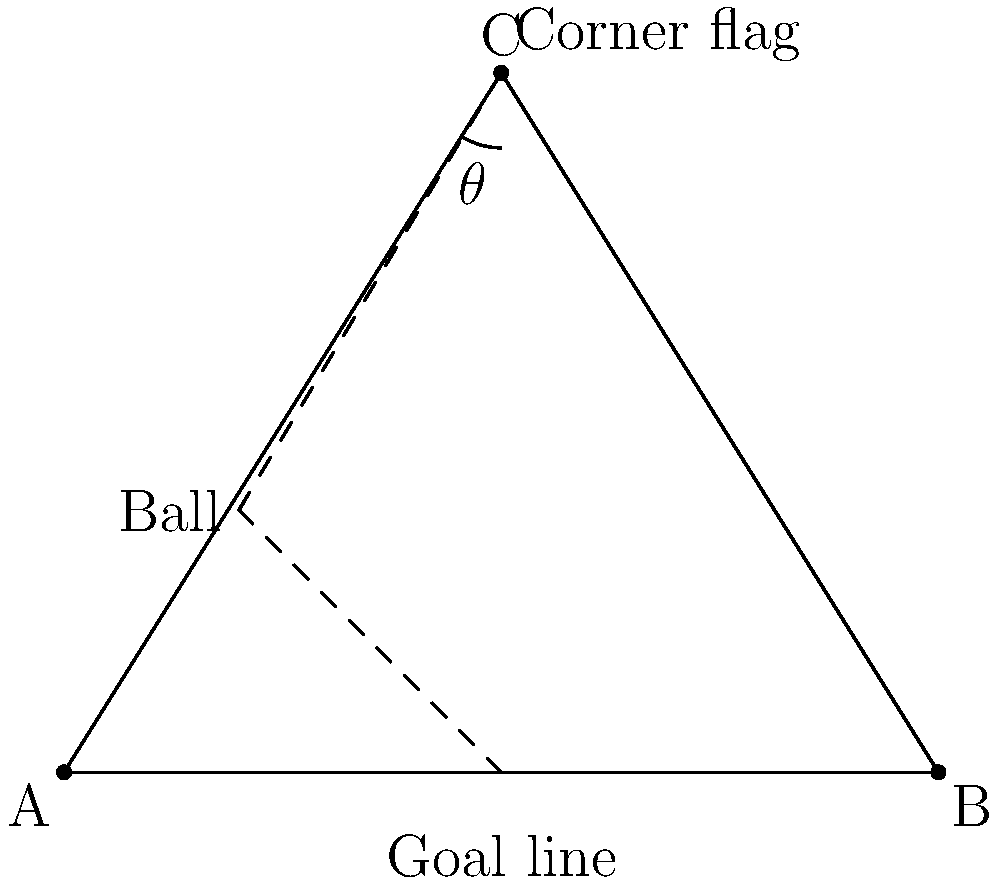During a crucial match, a player is preparing to take a corner kick. The corner flag is 8 meters away from the goal line, and the width of the goal is 10 meters. If the ball is placed 3 meters away from the corner flag along the goal line, what is the angle $\theta$ between the ball, corner flag, and the center of the goal? Let's approach this step-by-step:

1) First, we need to identify the triangle formed by the ball, corner flag, and center of the goal. Let's call the ball point A, the corner flag point C, and the center of the goal point B.

2) We know that:
   - The distance from the corner flag to the goal line is 8 meters (height of the triangle)
   - The width of the goal is 10 meters, so the distance from the corner to the center of the goal is 5 meters (half of 10)
   - The ball is placed 3 meters from the corner flag along the goal line

3) We can now determine the coordinates of our points if we set the corner of the field as the origin (0,0):
   A (ball): (3,0)
   B (goal center): (5,0)
   C (corner flag): (0,8)

4) To find angle $\theta$, we can use the law of cosines:

   $\cos \theta = \frac{AC^2 + AB^2 - BC^2}{2(AC)(AB)}$

   Where:
   $AC = \sqrt{3^2 + 8^2} = \sqrt{73}$
   $AB = 5 - 3 = 2$
   $BC = \sqrt{5^2 + 8^2} = \sqrt{89}$

5) Substituting these values:

   $\cos \theta = \frac{73 + 4 - 89}{2\sqrt{73} \cdot 2} = \frac{-12}{4\sqrt{73}} = -\frac{3}{\sqrt{73}}$

6) To get $\theta$, we take the inverse cosine (arccos):

   $\theta = \arccos(-\frac{3}{\sqrt{73}})$

7) Calculating this gives us approximately 1.9234 radians or 110.2°
Answer: $110.2°$ 